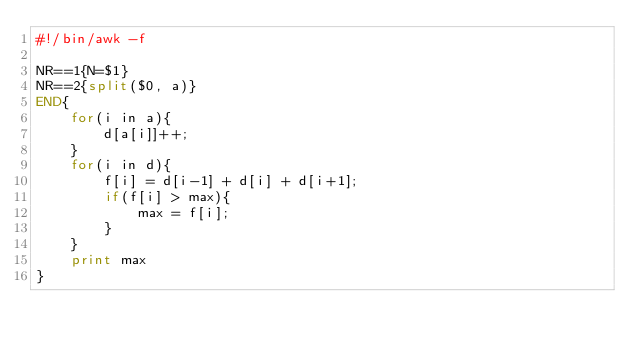<code> <loc_0><loc_0><loc_500><loc_500><_Awk_>#!/bin/awk -f

NR==1{N=$1}
NR==2{split($0, a)}
END{
    for(i in a){
        d[a[i]]++;
    }
    for(i in d){
        f[i] = d[i-1] + d[i] + d[i+1];
        if(f[i] > max){
            max = f[i];
        }
    }
    print max
}
</code> 